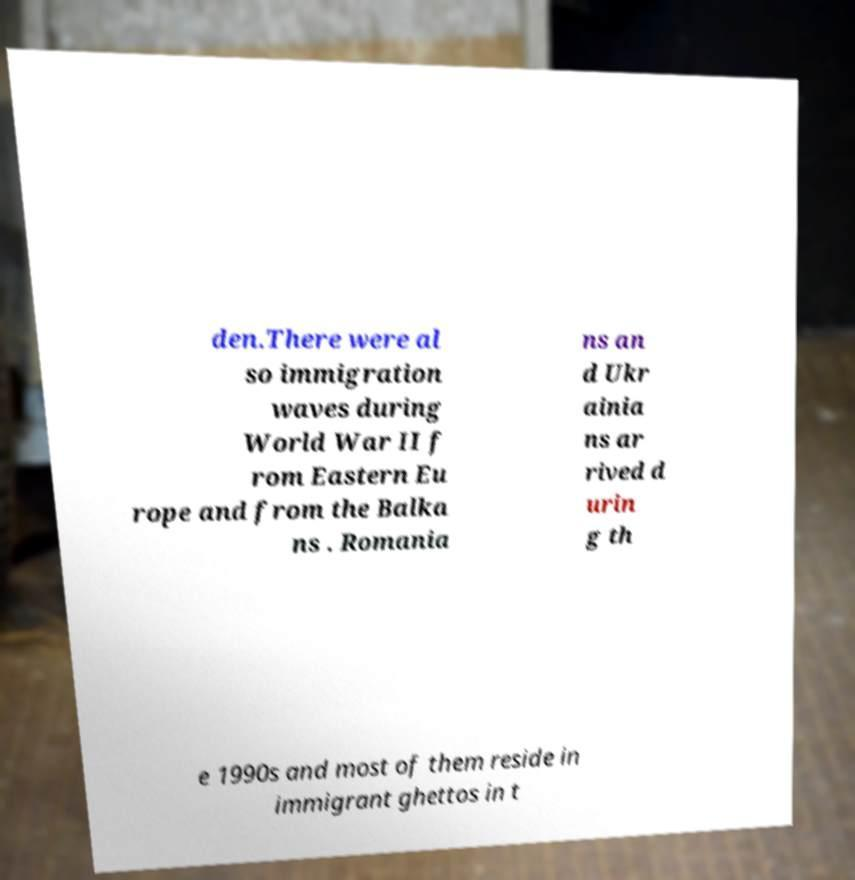Can you accurately transcribe the text from the provided image for me? den.There were al so immigration waves during World War II f rom Eastern Eu rope and from the Balka ns . Romania ns an d Ukr ainia ns ar rived d urin g th e 1990s and most of them reside in immigrant ghettos in t 